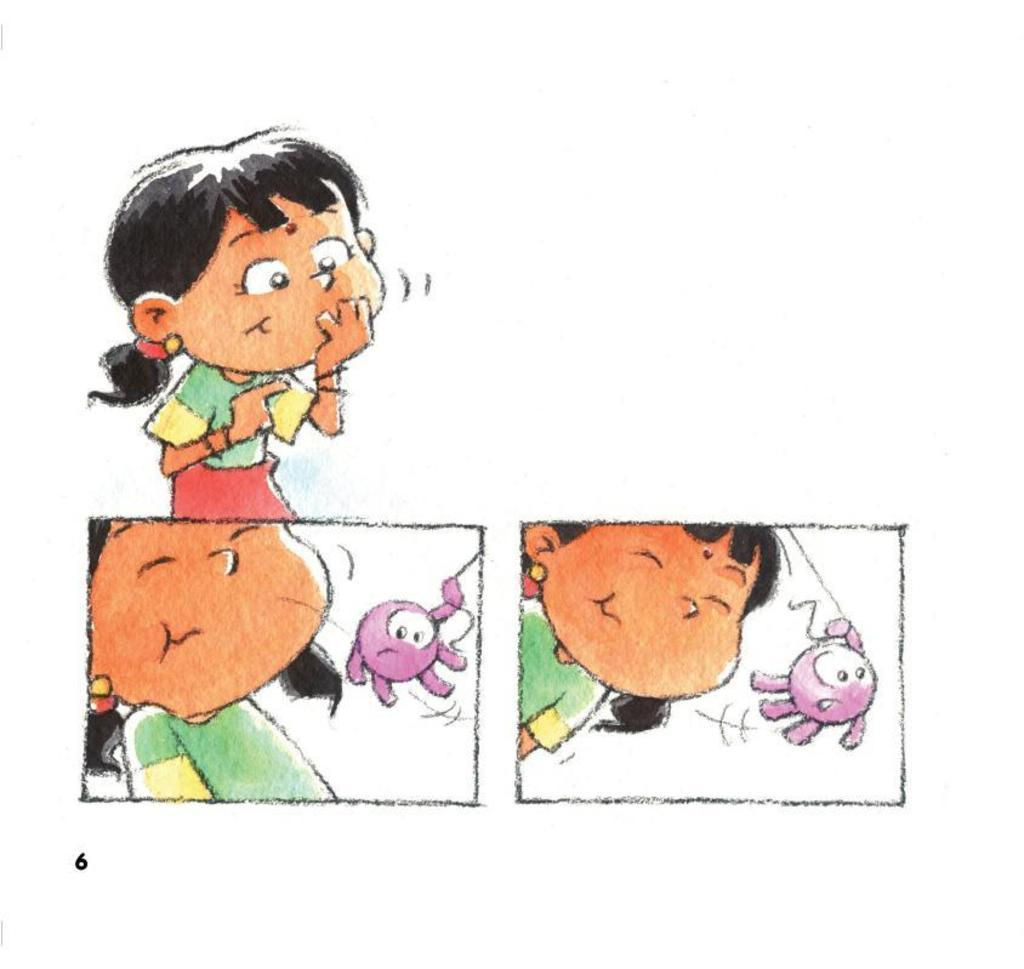What is depicted in the image? There is a drawing of a girl in the image. Is there any additional information provided in the image? Yes, there is a number in the bottom left corner of the image. What song is the girl singing in the image? There is no indication in the image that the girl is singing a song. What color is the queen's dress in the image? There is no queen present in the image, only a drawing of a girl. 